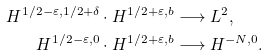<formula> <loc_0><loc_0><loc_500><loc_500>H ^ { 1 / 2 - \varepsilon , 1 / 2 + \delta } \cdot H ^ { 1 / 2 + \varepsilon , b } & \longrightarrow L ^ { 2 } , \\ H ^ { 1 / 2 - \varepsilon , 0 } \cdot H ^ { 1 / 2 + \varepsilon , b } & \longrightarrow H ^ { - N , 0 } .</formula> 